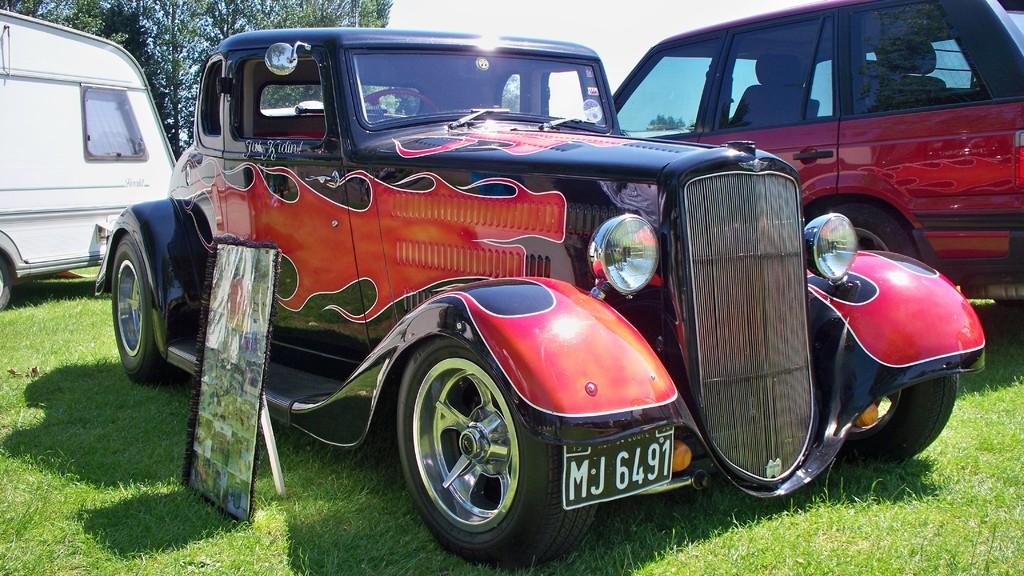What type of vehicles can be seen in the image? There are vehicles on the grass in the image. What can be seen in the background of the image? There is a tree and the sky visible in the background of the image. How many fangs can be seen on the vehicles in the image? There are no fangs present on the vehicles in the image, as vehicles do not have fangs. 